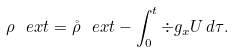<formula> <loc_0><loc_0><loc_500><loc_500>\rho _ { \ } e x t = \mathring { \rho } _ { \ } e x t - \int _ { 0 } ^ { t } { \div g _ { x } U \, d \tau } .</formula> 